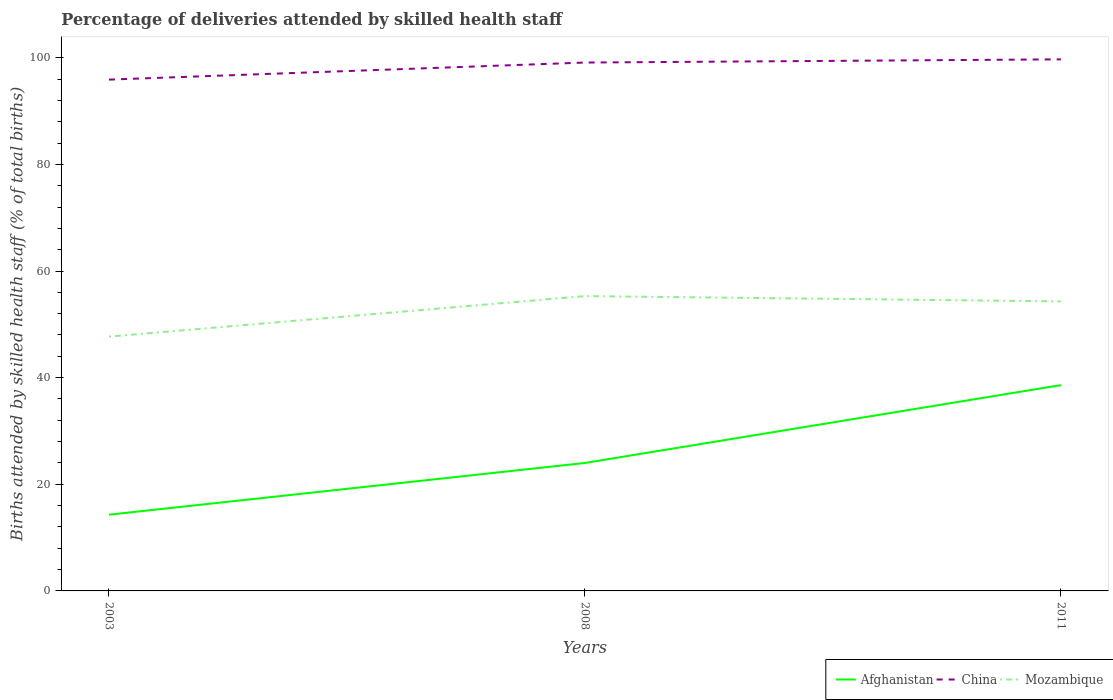Is the number of lines equal to the number of legend labels?
Provide a short and direct response. Yes. Across all years, what is the maximum percentage of births attended by skilled health staff in China?
Give a very brief answer. 95.9. In which year was the percentage of births attended by skilled health staff in Afghanistan maximum?
Give a very brief answer. 2003. What is the total percentage of births attended by skilled health staff in Mozambique in the graph?
Make the answer very short. -6.6. What is the difference between the highest and the second highest percentage of births attended by skilled health staff in China?
Offer a terse response. 3.8. Is the percentage of births attended by skilled health staff in Afghanistan strictly greater than the percentage of births attended by skilled health staff in Mozambique over the years?
Give a very brief answer. Yes. How many lines are there?
Your response must be concise. 3. What is the difference between two consecutive major ticks on the Y-axis?
Your answer should be very brief. 20. Are the values on the major ticks of Y-axis written in scientific E-notation?
Keep it short and to the point. No. Does the graph contain any zero values?
Make the answer very short. No. Where does the legend appear in the graph?
Make the answer very short. Bottom right. What is the title of the graph?
Your answer should be very brief. Percentage of deliveries attended by skilled health staff. What is the label or title of the X-axis?
Offer a terse response. Years. What is the label or title of the Y-axis?
Your answer should be compact. Births attended by skilled health staff (% of total births). What is the Births attended by skilled health staff (% of total births) of Afghanistan in 2003?
Keep it short and to the point. 14.3. What is the Births attended by skilled health staff (% of total births) in China in 2003?
Keep it short and to the point. 95.9. What is the Births attended by skilled health staff (% of total births) in Mozambique in 2003?
Keep it short and to the point. 47.7. What is the Births attended by skilled health staff (% of total births) in Afghanistan in 2008?
Your answer should be compact. 24. What is the Births attended by skilled health staff (% of total births) of China in 2008?
Provide a short and direct response. 99.1. What is the Births attended by skilled health staff (% of total births) of Mozambique in 2008?
Provide a succinct answer. 55.3. What is the Births attended by skilled health staff (% of total births) in Afghanistan in 2011?
Ensure brevity in your answer.  38.6. What is the Births attended by skilled health staff (% of total births) of China in 2011?
Your answer should be very brief. 99.7. What is the Births attended by skilled health staff (% of total births) in Mozambique in 2011?
Your answer should be very brief. 54.3. Across all years, what is the maximum Births attended by skilled health staff (% of total births) in Afghanistan?
Provide a short and direct response. 38.6. Across all years, what is the maximum Births attended by skilled health staff (% of total births) in China?
Offer a terse response. 99.7. Across all years, what is the maximum Births attended by skilled health staff (% of total births) of Mozambique?
Provide a succinct answer. 55.3. Across all years, what is the minimum Births attended by skilled health staff (% of total births) of China?
Give a very brief answer. 95.9. Across all years, what is the minimum Births attended by skilled health staff (% of total births) of Mozambique?
Keep it short and to the point. 47.7. What is the total Births attended by skilled health staff (% of total births) of Afghanistan in the graph?
Offer a very short reply. 76.9. What is the total Births attended by skilled health staff (% of total births) in China in the graph?
Offer a terse response. 294.7. What is the total Births attended by skilled health staff (% of total births) of Mozambique in the graph?
Keep it short and to the point. 157.3. What is the difference between the Births attended by skilled health staff (% of total births) of China in 2003 and that in 2008?
Your response must be concise. -3.2. What is the difference between the Births attended by skilled health staff (% of total births) in Mozambique in 2003 and that in 2008?
Your answer should be very brief. -7.6. What is the difference between the Births attended by skilled health staff (% of total births) of Afghanistan in 2003 and that in 2011?
Provide a succinct answer. -24.3. What is the difference between the Births attended by skilled health staff (% of total births) in China in 2003 and that in 2011?
Provide a short and direct response. -3.8. What is the difference between the Births attended by skilled health staff (% of total births) of Mozambique in 2003 and that in 2011?
Make the answer very short. -6.6. What is the difference between the Births attended by skilled health staff (% of total births) of Afghanistan in 2008 and that in 2011?
Offer a very short reply. -14.6. What is the difference between the Births attended by skilled health staff (% of total births) in China in 2008 and that in 2011?
Your answer should be compact. -0.6. What is the difference between the Births attended by skilled health staff (% of total births) in Afghanistan in 2003 and the Births attended by skilled health staff (% of total births) in China in 2008?
Your answer should be compact. -84.8. What is the difference between the Births attended by skilled health staff (% of total births) of Afghanistan in 2003 and the Births attended by skilled health staff (% of total births) of Mozambique in 2008?
Give a very brief answer. -41. What is the difference between the Births attended by skilled health staff (% of total births) in China in 2003 and the Births attended by skilled health staff (% of total births) in Mozambique in 2008?
Your response must be concise. 40.6. What is the difference between the Births attended by skilled health staff (% of total births) in Afghanistan in 2003 and the Births attended by skilled health staff (% of total births) in China in 2011?
Give a very brief answer. -85.4. What is the difference between the Births attended by skilled health staff (% of total births) in China in 2003 and the Births attended by skilled health staff (% of total births) in Mozambique in 2011?
Ensure brevity in your answer.  41.6. What is the difference between the Births attended by skilled health staff (% of total births) in Afghanistan in 2008 and the Births attended by skilled health staff (% of total births) in China in 2011?
Offer a terse response. -75.7. What is the difference between the Births attended by skilled health staff (% of total births) in Afghanistan in 2008 and the Births attended by skilled health staff (% of total births) in Mozambique in 2011?
Give a very brief answer. -30.3. What is the difference between the Births attended by skilled health staff (% of total births) in China in 2008 and the Births attended by skilled health staff (% of total births) in Mozambique in 2011?
Offer a terse response. 44.8. What is the average Births attended by skilled health staff (% of total births) in Afghanistan per year?
Provide a succinct answer. 25.63. What is the average Births attended by skilled health staff (% of total births) in China per year?
Give a very brief answer. 98.23. What is the average Births attended by skilled health staff (% of total births) of Mozambique per year?
Your answer should be compact. 52.43. In the year 2003, what is the difference between the Births attended by skilled health staff (% of total births) of Afghanistan and Births attended by skilled health staff (% of total births) of China?
Your response must be concise. -81.6. In the year 2003, what is the difference between the Births attended by skilled health staff (% of total births) in Afghanistan and Births attended by skilled health staff (% of total births) in Mozambique?
Your answer should be compact. -33.4. In the year 2003, what is the difference between the Births attended by skilled health staff (% of total births) in China and Births attended by skilled health staff (% of total births) in Mozambique?
Offer a terse response. 48.2. In the year 2008, what is the difference between the Births attended by skilled health staff (% of total births) of Afghanistan and Births attended by skilled health staff (% of total births) of China?
Ensure brevity in your answer.  -75.1. In the year 2008, what is the difference between the Births attended by skilled health staff (% of total births) of Afghanistan and Births attended by skilled health staff (% of total births) of Mozambique?
Make the answer very short. -31.3. In the year 2008, what is the difference between the Births attended by skilled health staff (% of total births) in China and Births attended by skilled health staff (% of total births) in Mozambique?
Offer a terse response. 43.8. In the year 2011, what is the difference between the Births attended by skilled health staff (% of total births) in Afghanistan and Births attended by skilled health staff (% of total births) in China?
Your response must be concise. -61.1. In the year 2011, what is the difference between the Births attended by skilled health staff (% of total births) in Afghanistan and Births attended by skilled health staff (% of total births) in Mozambique?
Provide a succinct answer. -15.7. In the year 2011, what is the difference between the Births attended by skilled health staff (% of total births) of China and Births attended by skilled health staff (% of total births) of Mozambique?
Provide a succinct answer. 45.4. What is the ratio of the Births attended by skilled health staff (% of total births) of Afghanistan in 2003 to that in 2008?
Provide a succinct answer. 0.6. What is the ratio of the Births attended by skilled health staff (% of total births) of Mozambique in 2003 to that in 2008?
Make the answer very short. 0.86. What is the ratio of the Births attended by skilled health staff (% of total births) in Afghanistan in 2003 to that in 2011?
Your response must be concise. 0.37. What is the ratio of the Births attended by skilled health staff (% of total births) of China in 2003 to that in 2011?
Ensure brevity in your answer.  0.96. What is the ratio of the Births attended by skilled health staff (% of total births) in Mozambique in 2003 to that in 2011?
Your answer should be compact. 0.88. What is the ratio of the Births attended by skilled health staff (% of total births) in Afghanistan in 2008 to that in 2011?
Offer a very short reply. 0.62. What is the ratio of the Births attended by skilled health staff (% of total births) in Mozambique in 2008 to that in 2011?
Offer a terse response. 1.02. What is the difference between the highest and the second highest Births attended by skilled health staff (% of total births) of Afghanistan?
Your response must be concise. 14.6. What is the difference between the highest and the lowest Births attended by skilled health staff (% of total births) of Afghanistan?
Your response must be concise. 24.3. What is the difference between the highest and the lowest Births attended by skilled health staff (% of total births) of Mozambique?
Ensure brevity in your answer.  7.6. 